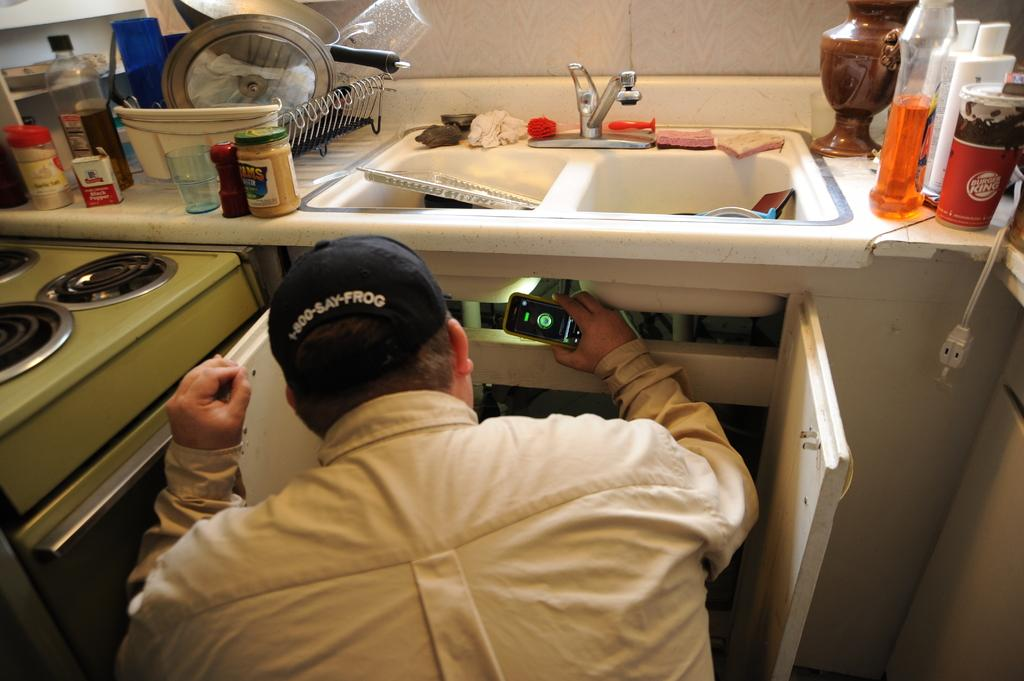<image>
Render a clear and concise summary of the photo. a man wearing a cap reading 1-800-SAY-FROG checking under a sink with his phone flashlight 